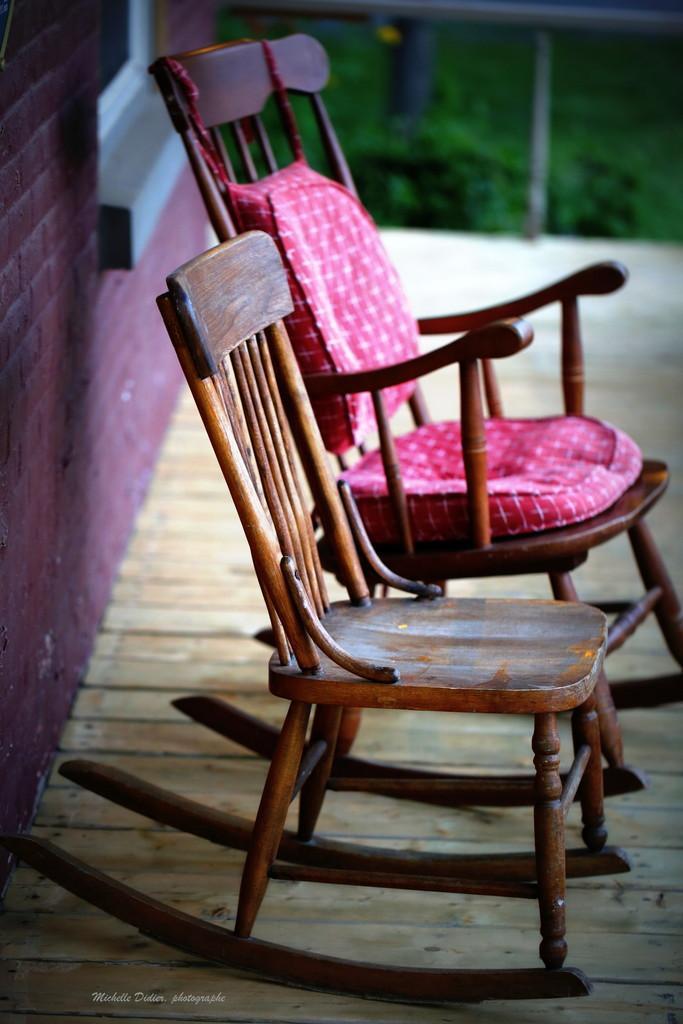How would you summarize this image in a sentence or two? In this image we can see chairs placed on the floor. In the background we can see grass and wall. 